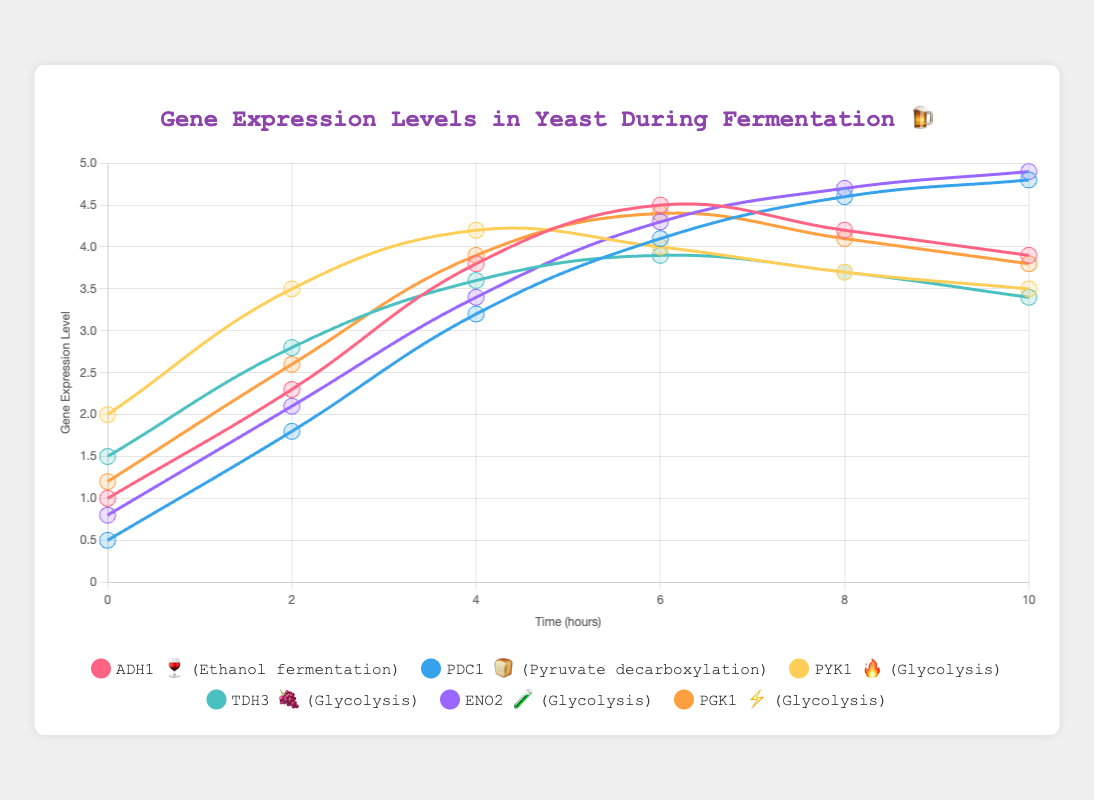What is the title of the figure? The title is displayed at the top of the figure in large, bold text. It provides a concise summary to describe what the chart represents.
Answer: Gene Expression Levels in Yeast During Fermentation 🍺 What are the time points at which the gene expression levels were measured? The x-axis of the chart shows the time points. The labels indicate the specific time intervals at which the measurements were taken.
Answer: [0, 2, 4, 6, 8, 10] Which gene has the highest expression level at the 10-hour mark? At the 10-hour mark, look for the gene with the highest point on the y-axis. Each line represents a different gene, and the highest y-value corresponds to the highest expression level.
Answer: ENO2 🧪 What metabolic pathway does ADH1 🍷 participate in? The legend and tooltips in the chart clarify the metabolic pathway associated with each gene. By identifying ADH1 🍷 in the legend, we can see the pathway it is involved in.
Answer: Ethanol fermentation How does the expression level of PDC1 🍞 change from 0 to 10 hours? Observing the line corresponding to PDC1 🍞 from the start to the end of the x-axis will show how its expression level varies over time. Follow the trend of the line carefully.
Answer: Increases Which gene's expression level peaks at the 8-hour mark? At the 8-hour mark on the x-axis, find the highest point among the gene expression levels and identify the corresponding gene from the legend.
Answer: PDC1 🍞 Which genes are involved in glycolysis? The legend of the chart lists each gene along with its associated metabolic pathway. Identify the genes labeled with the "Glycolysis" pathway.
Answer: PYK1 🔥, TDH3 🍇, ENO2 🧪, PGK1 ⚡ What is the average gene expression level of PGK1 ⚡ at all time points? To find the average, sum up the expression levels of PGK1 ⚡ at all time points and divide by the number of time points. Specifically, calculate (1.2 + 2.6 + 3.9 + 4.4 + 4.1 + 3.8) / 6.
Answer: 3.33 Compare the expression level of ADH1 🍷 and PDC1 🍞 at the 6-hour mark. Which is higher? Locate the 6-hour mark on the x-axis and compare the y-values of the points for ADH1 🍷 and PDC1 🍞 to see which is higher.
Answer: ADH1 🍷 Which gene shows the least variation in its expression levels over the measured time points? Examine the lines for each gene and determine which has the smallest range between its highest and lowest points (i.e., least fluctuation).
Answer: PYK1 🔥 